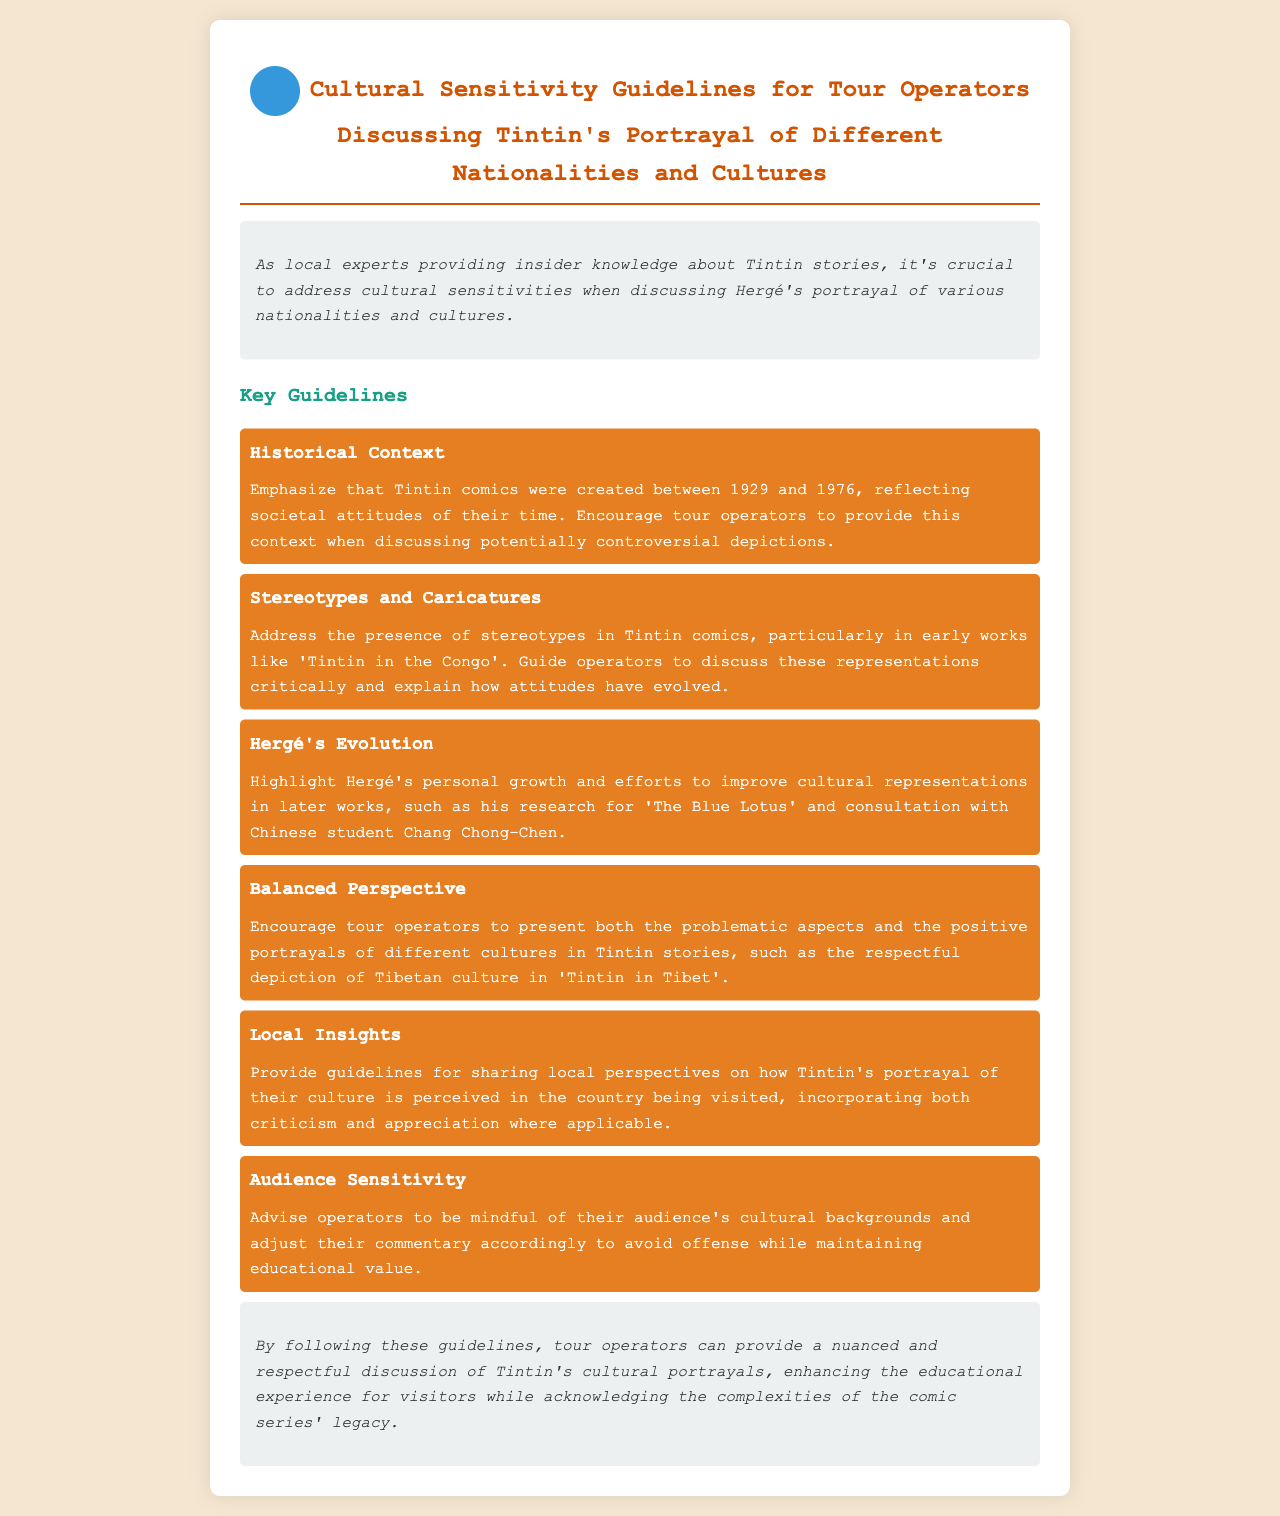what years were Tintin comics created? The document states that Tintin comics were created between 1929 and 1976.
Answer: 1929 and 1976 which comic is noted for its stereotypes? The policy document specifically mentions 'Tintin in the Congo' as an example of a comic with stereotypes.
Answer: Tintin in the Congo who was the Chinese student that Hergé consulted? The document identifies Chang Chong-Chen as the Chinese student consulted for cultural representation.
Answer: Chang Chong-Chen what positive aspect is highlighted about Tintin in Tibet? The guidelines encourage a respectful depiction of Tibetan culture in 'Tintin in Tibet'.
Answer: respectful depiction of Tibetan culture what is emphasized for tour operators regarding their audience? The document advises operators to be mindful of their audience's cultural backgrounds.
Answer: audience's cultural backgrounds how should tour operators approach Hergé's evolution? Tour operators should highlight Hergé's personal growth and efforts to improve cultural representations.
Answer: Hergé's personal growth and efforts what type of representations should be discussed critically? The policy suggests that stereotypes and caricatures in early works should be discussed critically.
Answer: stereotypes and caricatures what is the main goal of following these guidelines? The guidelines aim to enhance the educational experience for visitors while respecting cultural complexities.
Answer: enhance the educational experience 